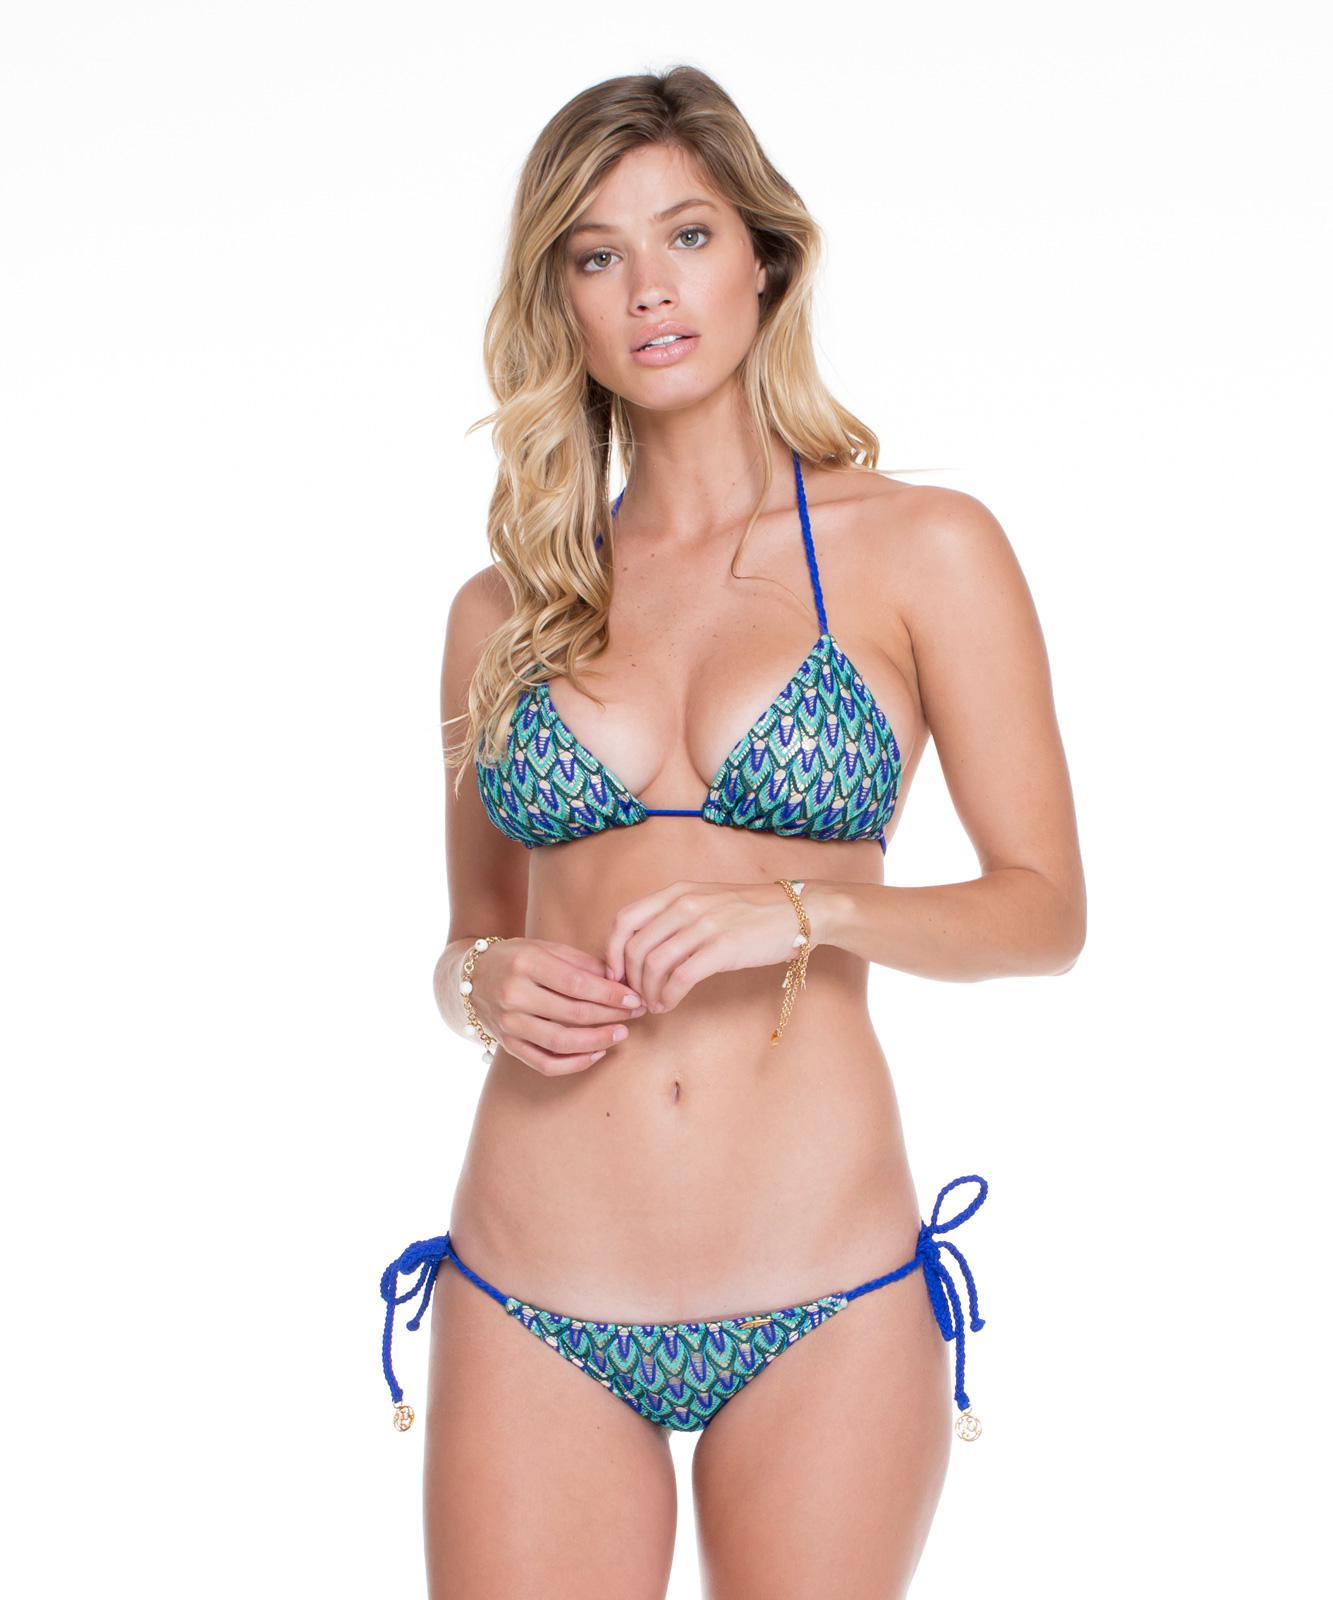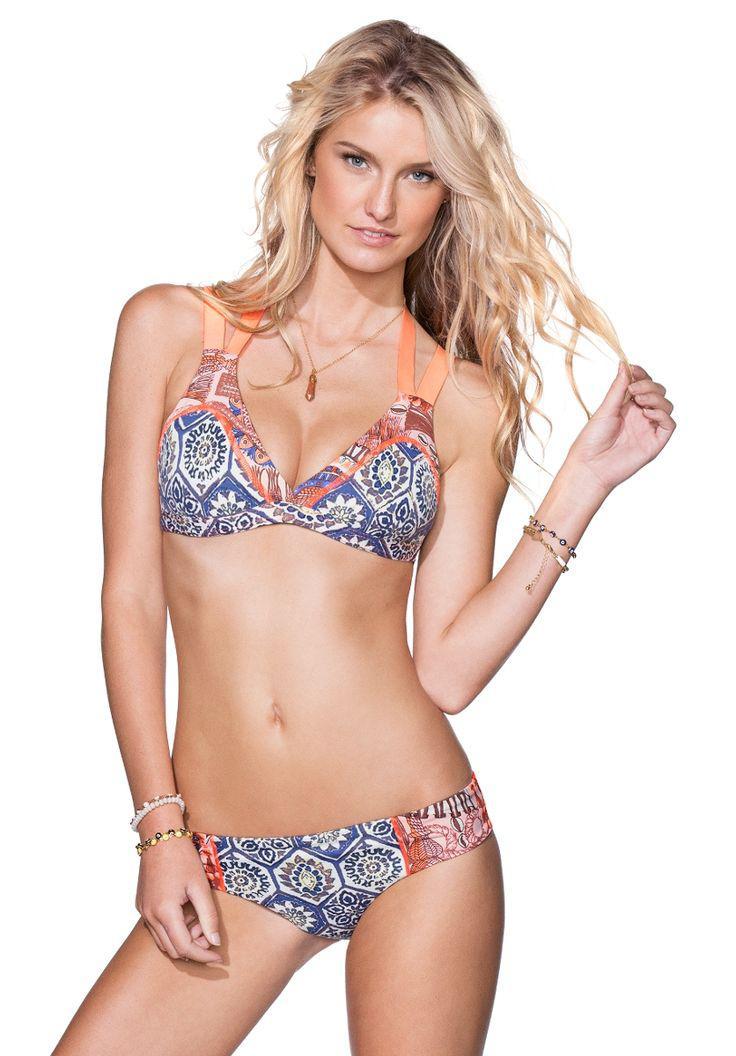The first image is the image on the left, the second image is the image on the right. For the images shown, is this caption "the model in the image on the left has her hand on her hip" true? Answer yes or no. No. The first image is the image on the left, the second image is the image on the right. For the images displayed, is the sentence "One bikini is tied with bows." factually correct? Answer yes or no. Yes. 